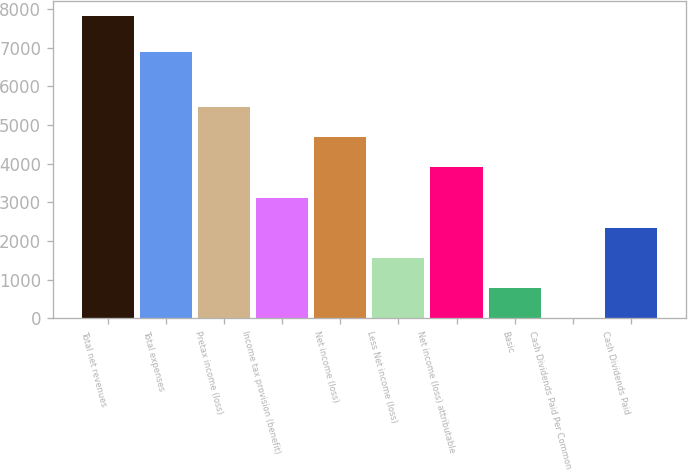Convert chart. <chart><loc_0><loc_0><loc_500><loc_500><bar_chart><fcel>Total net revenues<fcel>Total expenses<fcel>Pretax income (loss)<fcel>Income tax provision (benefit)<fcel>Net income (loss)<fcel>Less Net income (loss)<fcel>Net income (loss) attributable<fcel>Basic<fcel>Cash Dividends Paid Per Common<fcel>Cash Dividends Paid<nl><fcel>7805<fcel>6885<fcel>5463.69<fcel>3122.4<fcel>4683.26<fcel>1561.54<fcel>3902.83<fcel>781.11<fcel>0.68<fcel>2341.97<nl></chart> 